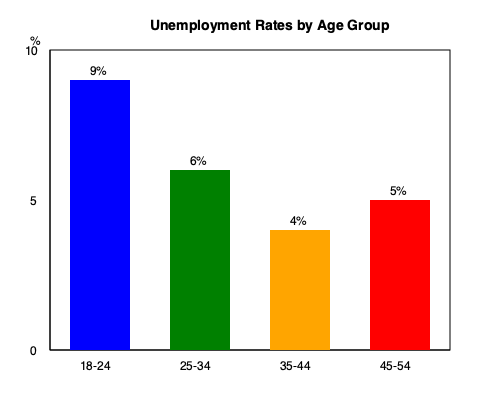Based on the bar graph showing unemployment rates across different age groups in the community, which age group has the highest unemployment rate, and what policy implications might this have for local workforce development initiatives? To answer this question, we need to analyze the bar graph and consider its implications for local policy:

1. Identify the highest unemployment rate:
   - 18-24 age group: 9%
   - 25-34 age group: 6%
   - 35-44 age group: 4%
   - 45-54 age group: 5%

   The highest unemployment rate is in the 18-24 age group at 9%.

2. Policy implications:
   a) Youth-focused initiatives: The high unemployment rate among young adults suggests a need for programs targeting this demographic.
   
   b) Education and training: Local policies could focus on providing vocational training, internships, or apprenticeships to help young people gain practical skills and work experience.
   
   c) Partnership with local businesses: Develop collaborations between educational institutions and local employers to create job opportunities and bridge the skills gap for young adults.
   
   d) Entrepreneurship support: Implement programs to encourage and support young entrepreneurs in starting their own businesses.
   
   e) Career counseling: Offer career guidance services to help young adults identify suitable career paths and develop job search skills.
   
   f) Address barriers: Investigate and address potential barriers to employment for young adults, such as transportation issues or lack of affordable childcare.
   
   g) Retention strategies: Develop policies to encourage local businesses to hire and retain young workers, possibly through tax incentives or subsidies.

3. Long-term economic impact: Addressing youth unemployment can lead to increased economic productivity, reduced social welfare costs, and improved community well-being.

4. Holistic approach: While focusing on the 18-24 age group, it's important to maintain support for other age groups to ensure balanced workforce development across the community.
Answer: The 18-24 age group has the highest unemployment rate (9%). Policy implications include youth-focused job training, education partnerships, and entrepreneurship support programs. 